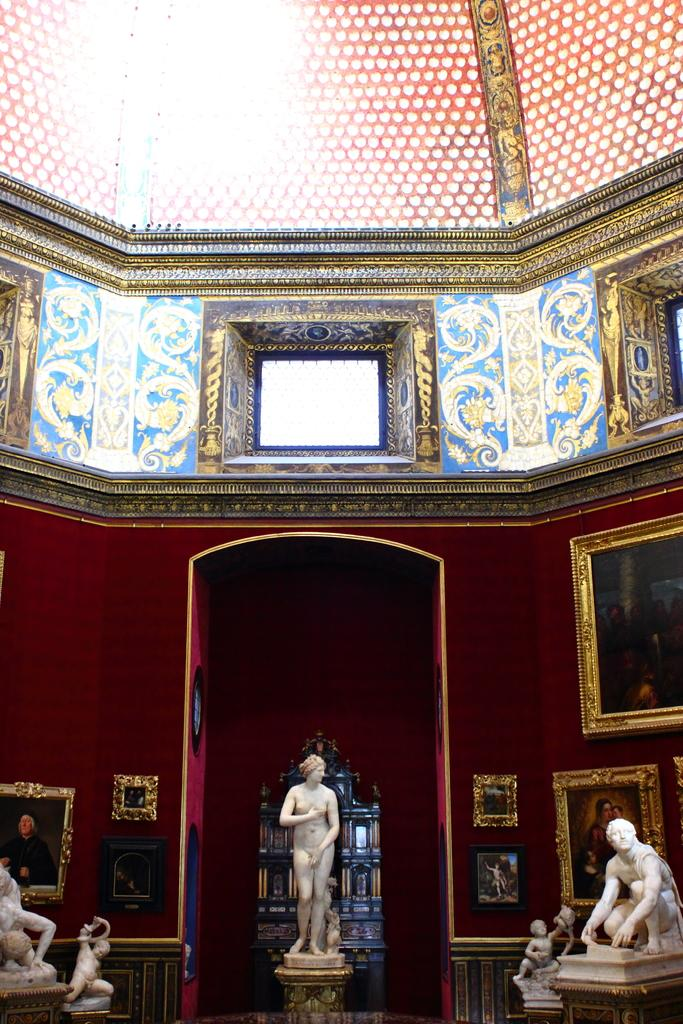What type of objects can be seen in the image? There are statues in the image. What else can be seen on the wall in the image? There are frames on the wall in the image. How many kittens are being guided by the statues in the image? There are no kittens present in the image, and the statues do not appear to be guiding anything. 